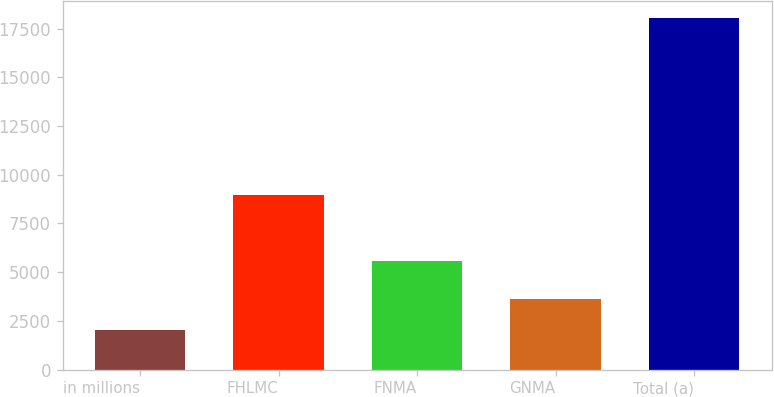<chart> <loc_0><loc_0><loc_500><loc_500><bar_chart><fcel>in millions<fcel>FHLMC<fcel>FNMA<fcel>GNMA<fcel>Total (a)<nl><fcel>2011<fcel>8984<fcel>5583<fcel>3613<fcel>18031<nl></chart> 